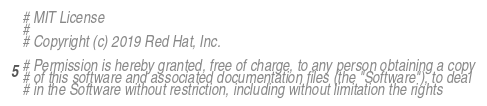<code> <loc_0><loc_0><loc_500><loc_500><_Python_># MIT License
#
# Copyright (c) 2019 Red Hat, Inc.

# Permission is hereby granted, free of charge, to any person obtaining a copy
# of this software and associated documentation files (the "Software"), to deal
# in the Software without restriction, including without limitation the rights</code> 